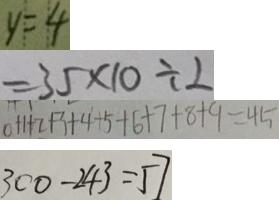<formula> <loc_0><loc_0><loc_500><loc_500>y = 4 
 = 3 5 \times 1 0 \div 2 
 0 + 1 + 2 + 3 + 4 + 5 + 6 + 7 + 8 + 9 = 4 5 
 3 0 0 - 2 4 3 = 5 7</formula> 